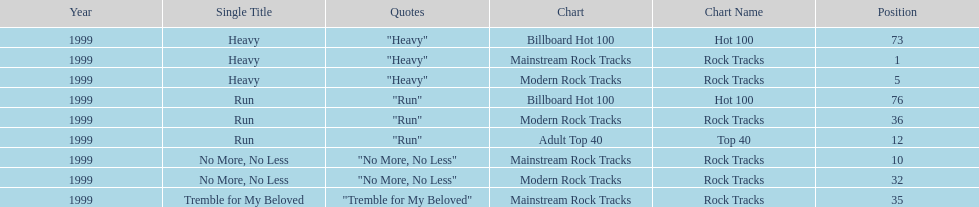How many singles from "dosage" appeared on the modern rock tracks charts? 3. 